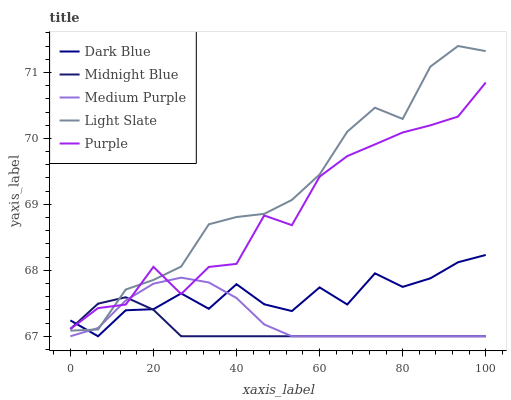Does Midnight Blue have the minimum area under the curve?
Answer yes or no. Yes. Does Light Slate have the maximum area under the curve?
Answer yes or no. Yes. Does Dark Blue have the minimum area under the curve?
Answer yes or no. No. Does Dark Blue have the maximum area under the curve?
Answer yes or no. No. Is Midnight Blue the smoothest?
Answer yes or no. Yes. Is Purple the roughest?
Answer yes or no. Yes. Is Dark Blue the smoothest?
Answer yes or no. No. Is Dark Blue the roughest?
Answer yes or no. No. Does Purple have the lowest value?
Answer yes or no. No. Does Light Slate have the highest value?
Answer yes or no. Yes. Does Dark Blue have the highest value?
Answer yes or no. No. Does Medium Purple intersect Light Slate?
Answer yes or no. Yes. Is Medium Purple less than Light Slate?
Answer yes or no. No. Is Medium Purple greater than Light Slate?
Answer yes or no. No. 